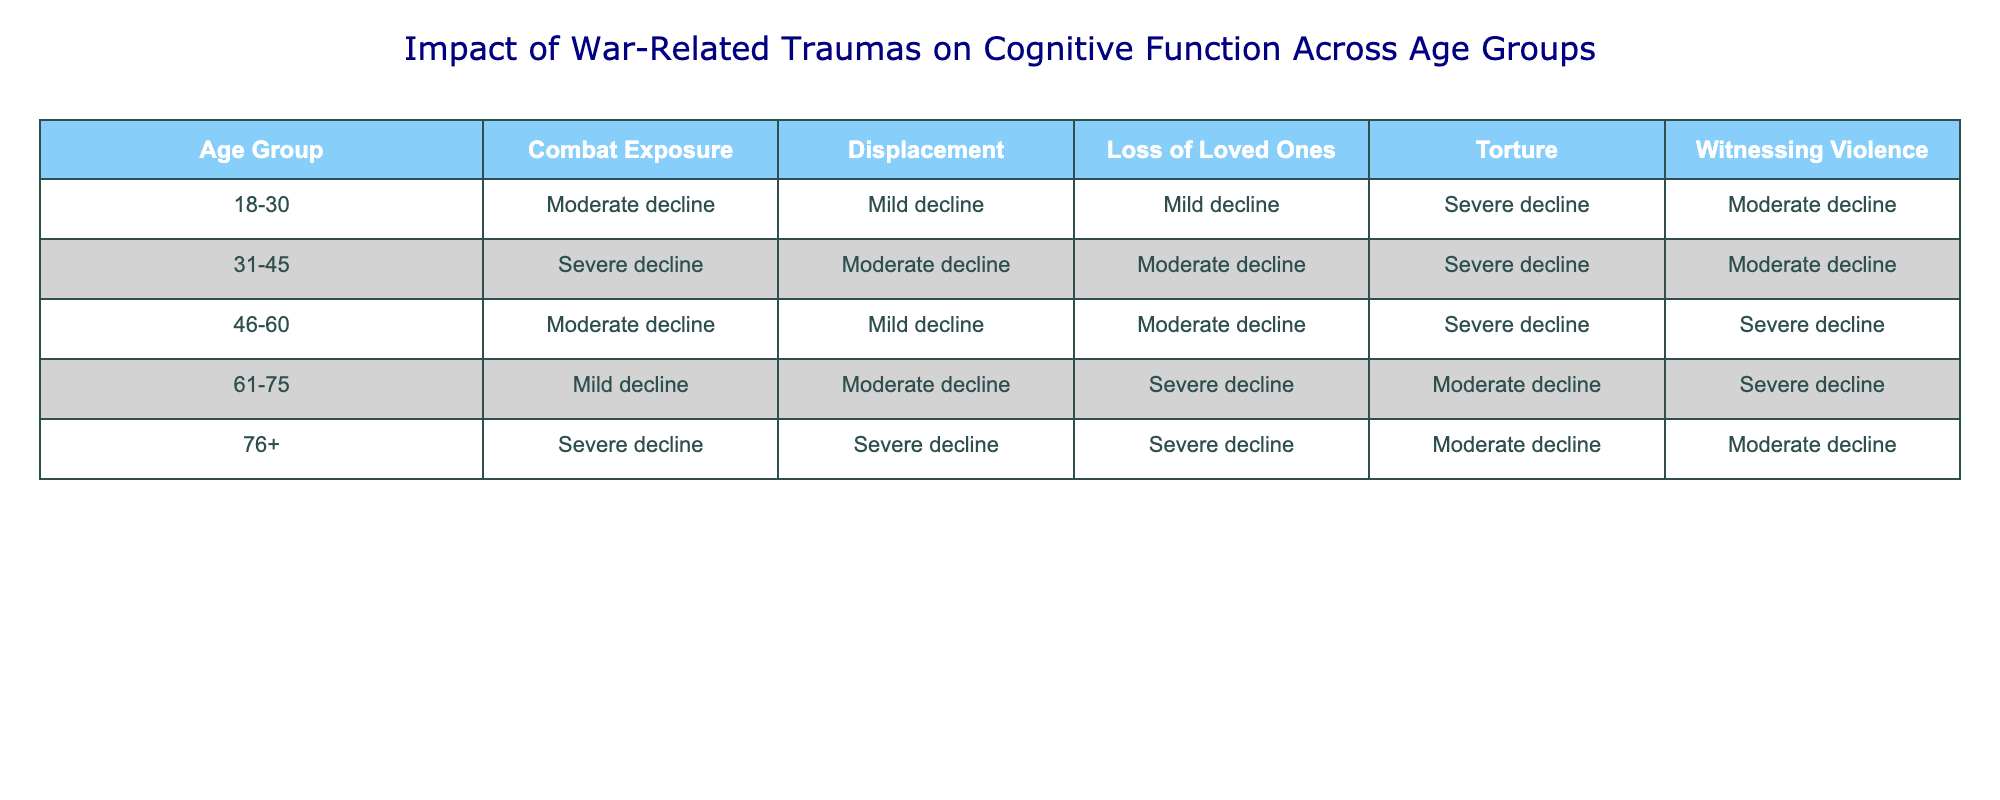What is the impact of combat exposure on cognitive function for the age group 31-45? The table indicates that the impact of combat exposure on cognitive function for the age group 31-45 is labeled as "Severe decline."
Answer: Severe decline Which age group shows the mildest decline in cognitive function due to witnessing violence? The age group 61-75 shows "Moderate decline" for witnessing violence, which is milder than the other age groups listed.
Answer: 61-75 Is there a consistent trend in the decline of cognitive function related to displacement across the age groups? The impact of displacement varies across the age groups, showing mild to severe declines, without a clear increasing or decreasing trend as it fluctuates.
Answer: No For the age group 76+, which trauma has the most severe effect on cognitive function? Looking at the table, the trauma "Loss of Loved Ones" shows a "Severe decline," which is the most severe effect compared to others in that age group.
Answer: Loss of Loved Ones Compare the effects of torture between the 18-30 and 46-60 age groups. The table shows that the 18-30 age group experiences a "Severe decline" due to torture, while the 46-60 age group also experiences a "Severe decline," meaning both age groups are affected severely by torture.
Answer: Both experience severe decline What is the trend of cognitive function decline due to combat exposure from age 18-30 to 76+? Analyzing the table, the trend starts with "Moderate decline" in the 18-30 age group, shifts to "Severe decline" in the 31-45 age group, and then slightly varies with "Moderate decline" in 46-60 and back to "Severe decline" in 76+.
Answer: Mixed trend In which age group is the impact of loss of loved ones the most severe? The age group 61-75 has the most severe impact ("Severe decline") for the trauma related to loss of loved ones compared to others.
Answer: 61-75 Are there any age groups that experience no decline in cognitive function from witnessing violence? The table indicates that all age groups experience at least a "Moderate decline," meaning no age group shows no decline.
Answer: No Which type of trauma consistently affects cognitive function with the severity of "Severe decline" in multiple age groups? The traumas of "Torture" and "Loss of Loved Ones" both have "Severe decline" across multiple age groups indicating a consistent severe impact.
Answer: Torture and Loss of Loved Ones How does the impact of combat exposure for age group 46-60 compare to that of displacement? For age group 46-60, combat exposure results in a "Moderate decline," while displacement is listed as "Mild decline," indicating that combat exposure has a greater impact.
Answer: Greater impact from combat exposure What is the overall impact of witnessing violence for the youngest age group compared to the oldest? The youngest age group (18-30) experiences a "Moderate decline" due to witnessing violence, while the oldest age group (76+) experiences a "Moderate decline" as well, showing no significant difference between the two.
Answer: No significant difference 